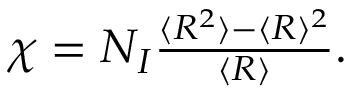<formula> <loc_0><loc_0><loc_500><loc_500>\begin{array} { r } { \chi = N _ { I } \frac { \langle R ^ { 2 } \rangle - \langle R \rangle ^ { 2 } } { \langle R \rangle } . } \end{array}</formula> 